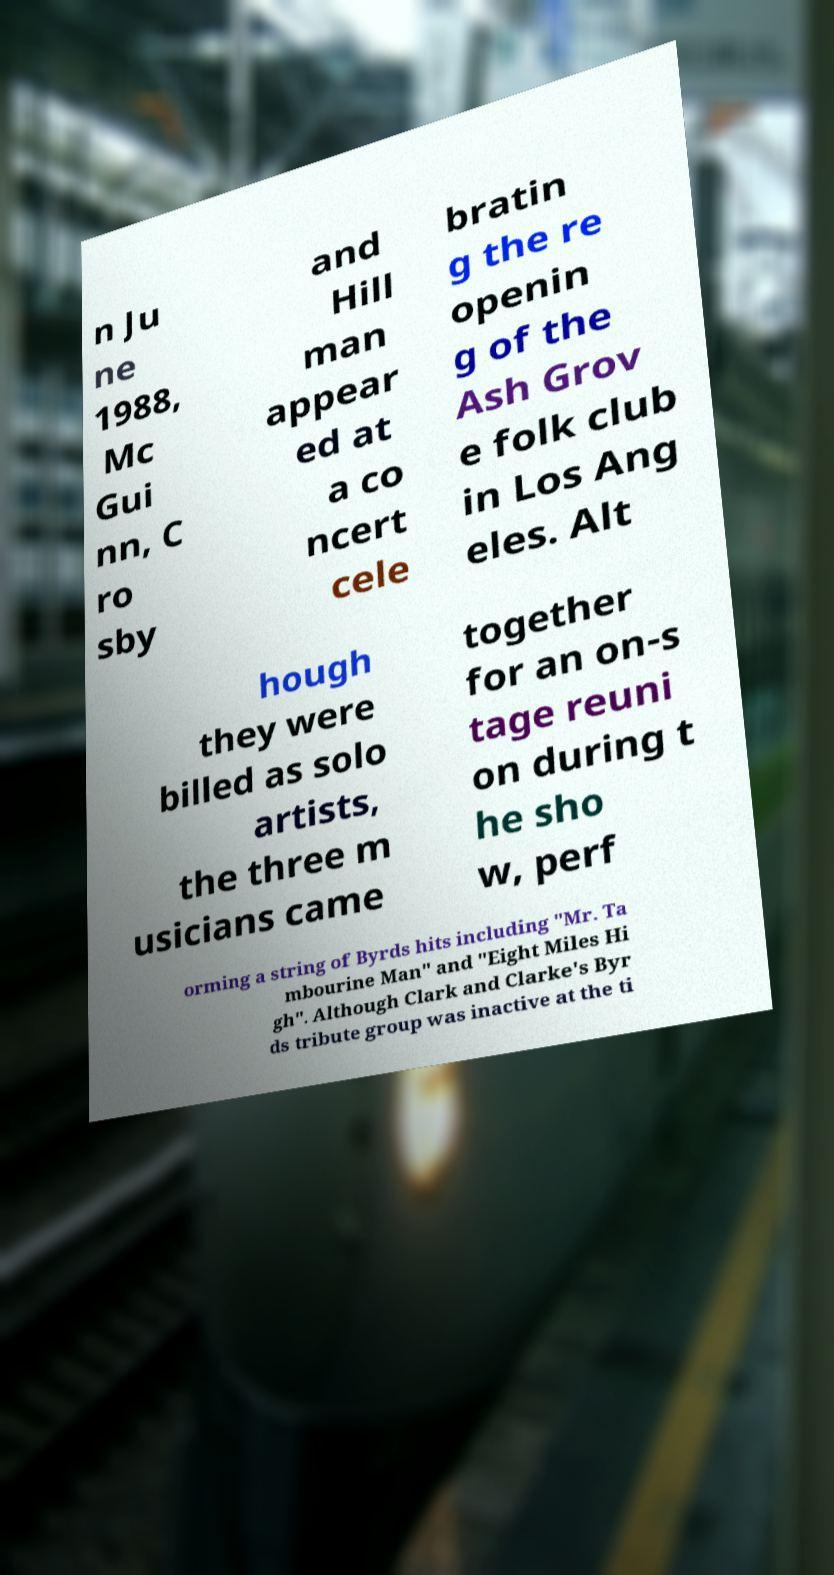There's text embedded in this image that I need extracted. Can you transcribe it verbatim? n Ju ne 1988, Mc Gui nn, C ro sby and Hill man appear ed at a co ncert cele bratin g the re openin g of the Ash Grov e folk club in Los Ang eles. Alt hough they were billed as solo artists, the three m usicians came together for an on-s tage reuni on during t he sho w, perf orming a string of Byrds hits including "Mr. Ta mbourine Man" and "Eight Miles Hi gh". Although Clark and Clarke's Byr ds tribute group was inactive at the ti 